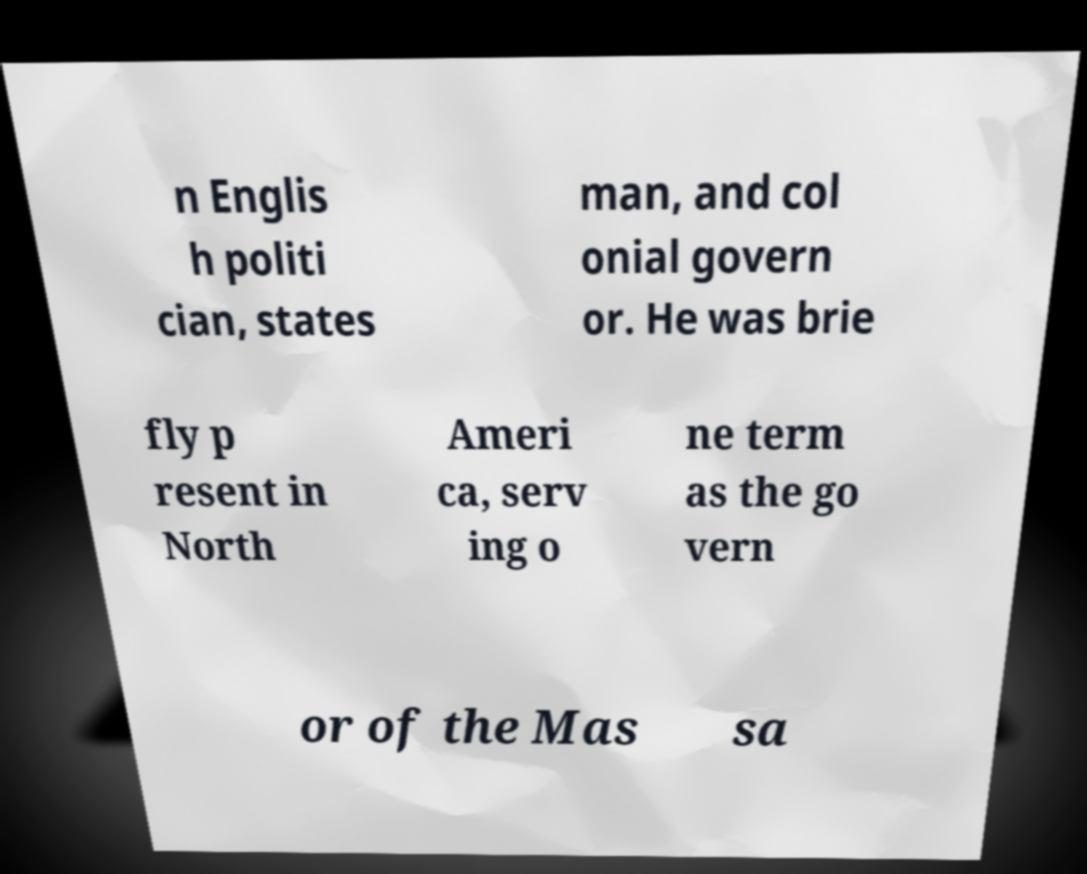I need the written content from this picture converted into text. Can you do that? n Englis h politi cian, states man, and col onial govern or. He was brie fly p resent in North Ameri ca, serv ing o ne term as the go vern or of the Mas sa 